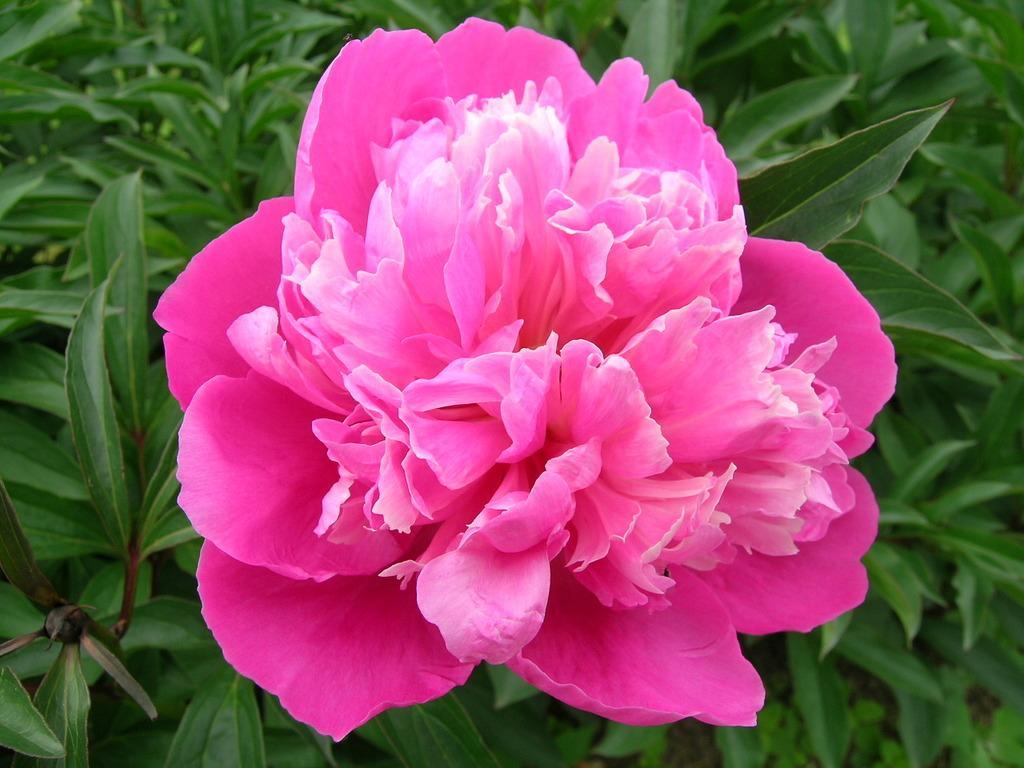How would you summarize this image in a sentence or two? In the picture I can see the pink color flower in the middle of the image and I can see the green leaves. 